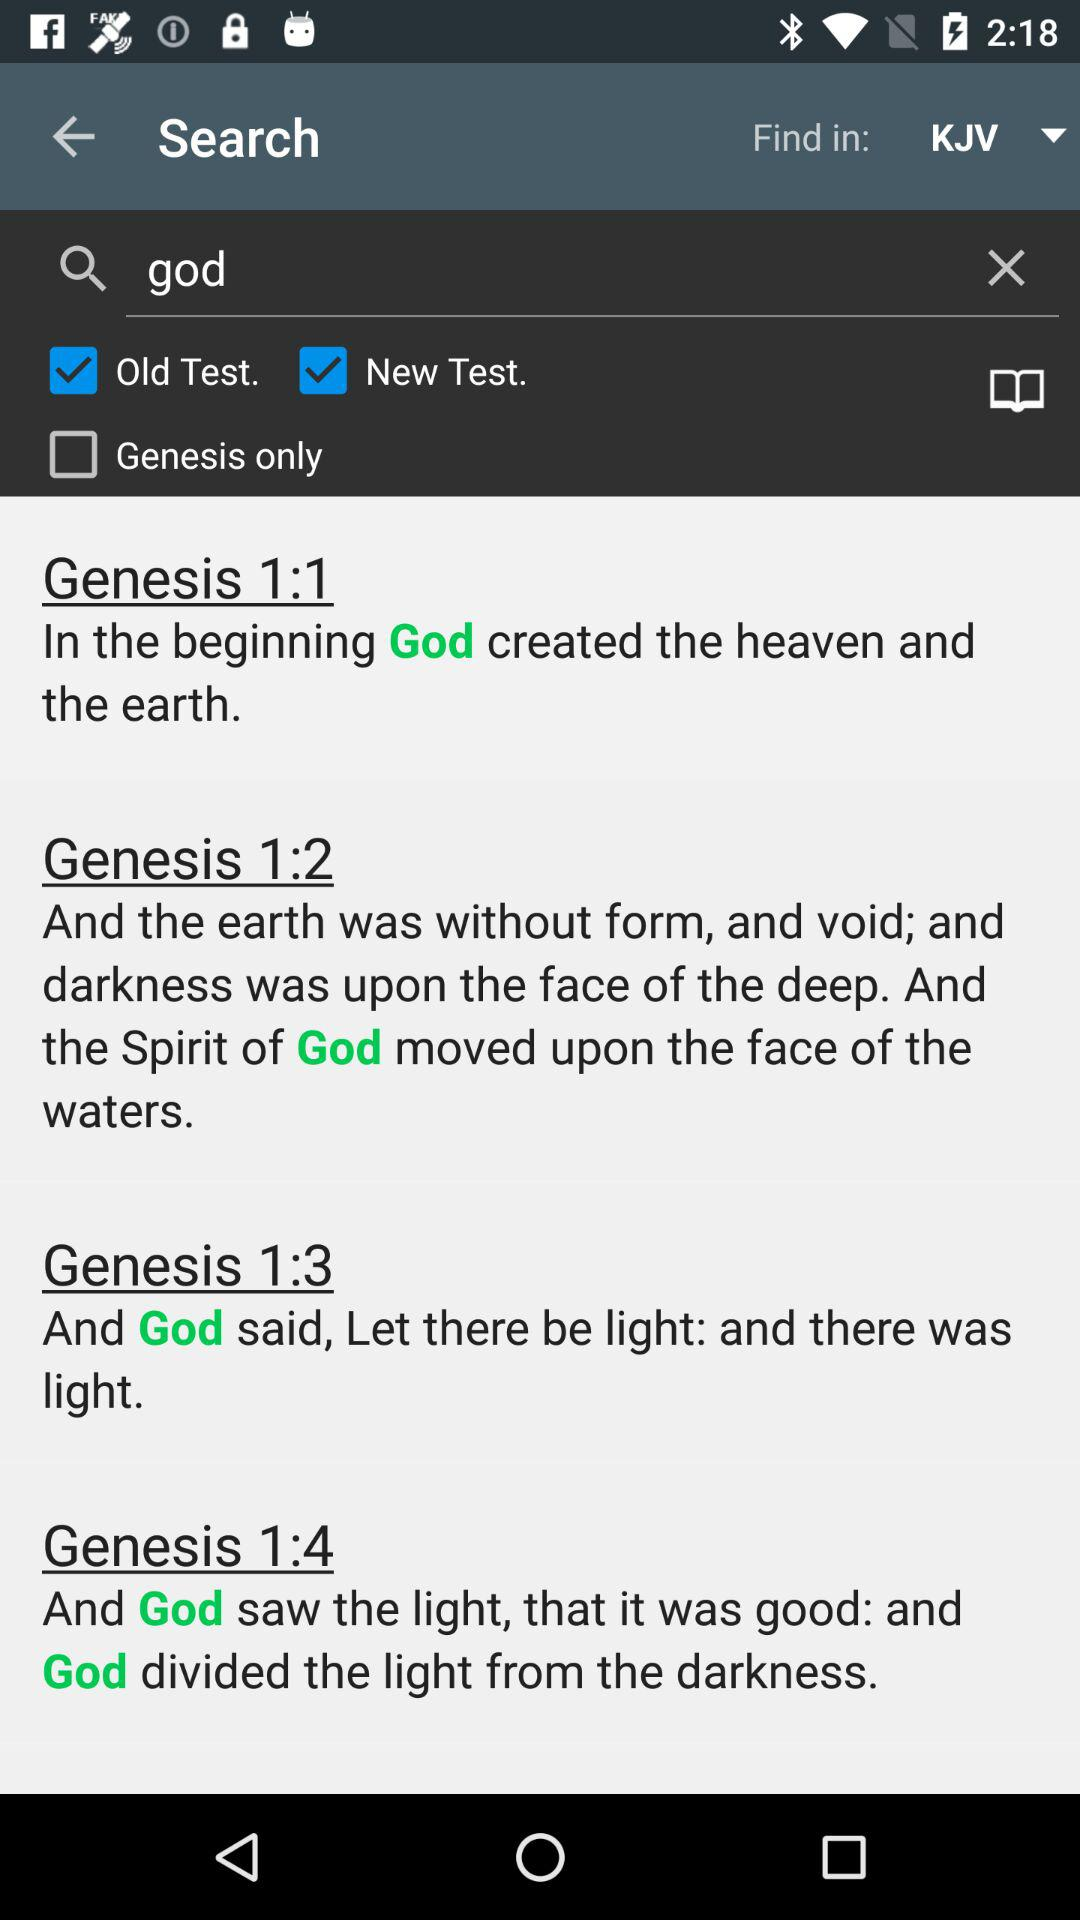What is in "Genesis 1:2"? The content in "Genesis 1:2" is "And the earth was without form, and void; and darkness was upon the face of the deep. And the Spirit of God moved upon the face of the waters". 